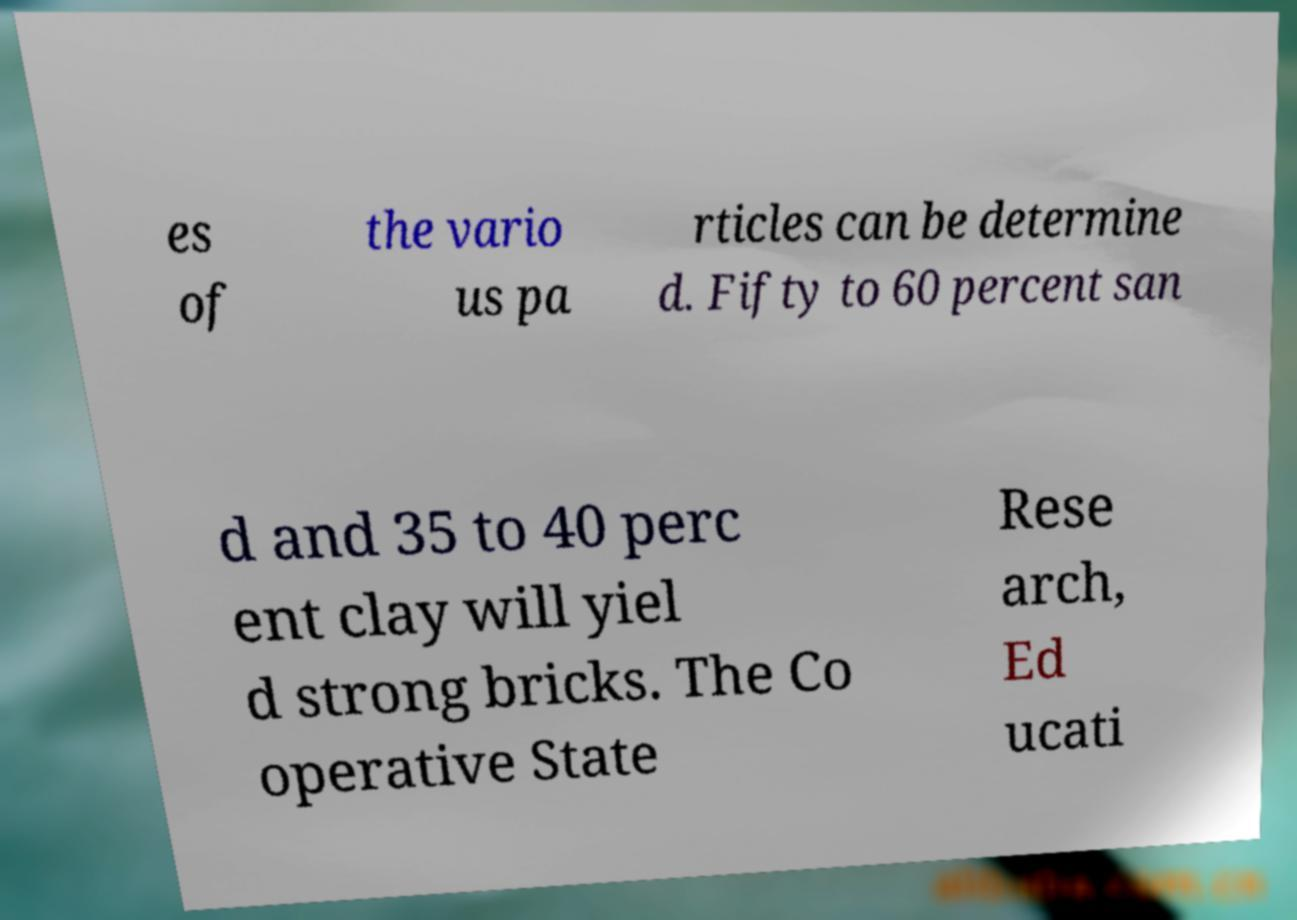For documentation purposes, I need the text within this image transcribed. Could you provide that? es of the vario us pa rticles can be determine d. Fifty to 60 percent san d and 35 to 40 perc ent clay will yiel d strong bricks. The Co operative State Rese arch, Ed ucati 